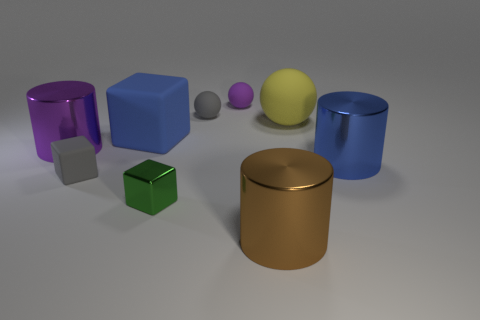How many things are big things behind the blue metal cylinder or brown cylinders?
Make the answer very short. 4. What number of other things are the same shape as the blue matte object?
Ensure brevity in your answer.  2. Is the shape of the gray object left of the small gray ball the same as  the large purple object?
Keep it short and to the point. No. There is a green metallic cube; are there any tiny objects left of it?
Your answer should be compact. Yes. What number of small things are either green cubes or purple things?
Your response must be concise. 2. Do the tiny purple sphere and the gray cube have the same material?
Provide a succinct answer. Yes. There is a metallic object that is the same color as the large rubber block; what size is it?
Your answer should be compact. Large. Are there any rubber objects that have the same color as the tiny shiny thing?
Ensure brevity in your answer.  No. There is a gray object that is made of the same material as the gray sphere; what size is it?
Your response must be concise. Small. What is the shape of the large blue thing that is in front of the cube behind the big cylinder on the left side of the tiny purple matte thing?
Your answer should be compact. Cylinder. 